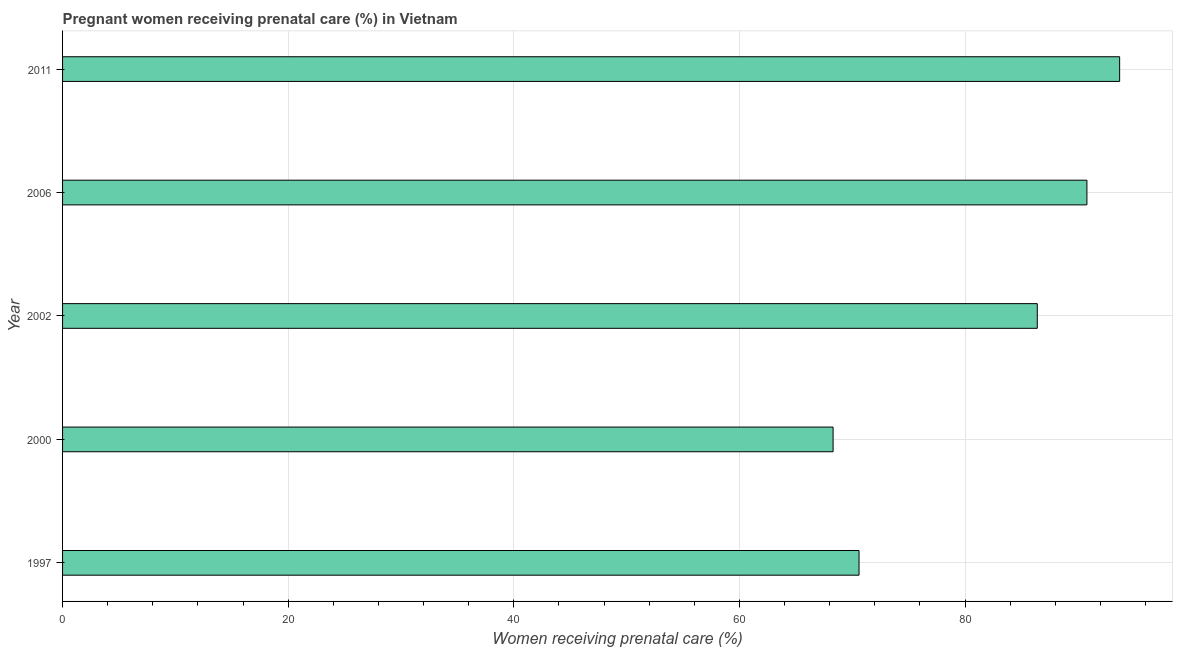Does the graph contain grids?
Offer a very short reply. Yes. What is the title of the graph?
Make the answer very short. Pregnant women receiving prenatal care (%) in Vietnam. What is the label or title of the X-axis?
Your response must be concise. Women receiving prenatal care (%). What is the percentage of pregnant women receiving prenatal care in 1997?
Give a very brief answer. 70.6. Across all years, what is the maximum percentage of pregnant women receiving prenatal care?
Your answer should be compact. 93.7. Across all years, what is the minimum percentage of pregnant women receiving prenatal care?
Offer a very short reply. 68.3. In which year was the percentage of pregnant women receiving prenatal care minimum?
Keep it short and to the point. 2000. What is the sum of the percentage of pregnant women receiving prenatal care?
Ensure brevity in your answer.  409.8. What is the difference between the percentage of pregnant women receiving prenatal care in 2006 and 2011?
Provide a succinct answer. -2.9. What is the average percentage of pregnant women receiving prenatal care per year?
Provide a succinct answer. 81.96. What is the median percentage of pregnant women receiving prenatal care?
Your response must be concise. 86.4. In how many years, is the percentage of pregnant women receiving prenatal care greater than 48 %?
Ensure brevity in your answer.  5. Do a majority of the years between 2000 and 2006 (inclusive) have percentage of pregnant women receiving prenatal care greater than 12 %?
Offer a very short reply. Yes. What is the ratio of the percentage of pregnant women receiving prenatal care in 1997 to that in 2006?
Ensure brevity in your answer.  0.78. Is the percentage of pregnant women receiving prenatal care in 2000 less than that in 2002?
Ensure brevity in your answer.  Yes. Is the difference between the percentage of pregnant women receiving prenatal care in 2002 and 2006 greater than the difference between any two years?
Your answer should be very brief. No. Is the sum of the percentage of pregnant women receiving prenatal care in 2002 and 2011 greater than the maximum percentage of pregnant women receiving prenatal care across all years?
Offer a very short reply. Yes. What is the difference between the highest and the lowest percentage of pregnant women receiving prenatal care?
Your answer should be compact. 25.4. How many bars are there?
Ensure brevity in your answer.  5. How many years are there in the graph?
Make the answer very short. 5. What is the Women receiving prenatal care (%) in 1997?
Your answer should be very brief. 70.6. What is the Women receiving prenatal care (%) of 2000?
Keep it short and to the point. 68.3. What is the Women receiving prenatal care (%) of 2002?
Your answer should be compact. 86.4. What is the Women receiving prenatal care (%) of 2006?
Ensure brevity in your answer.  90.8. What is the Women receiving prenatal care (%) of 2011?
Keep it short and to the point. 93.7. What is the difference between the Women receiving prenatal care (%) in 1997 and 2000?
Offer a terse response. 2.3. What is the difference between the Women receiving prenatal care (%) in 1997 and 2002?
Offer a very short reply. -15.8. What is the difference between the Women receiving prenatal care (%) in 1997 and 2006?
Offer a very short reply. -20.2. What is the difference between the Women receiving prenatal care (%) in 1997 and 2011?
Your response must be concise. -23.1. What is the difference between the Women receiving prenatal care (%) in 2000 and 2002?
Ensure brevity in your answer.  -18.1. What is the difference between the Women receiving prenatal care (%) in 2000 and 2006?
Your answer should be very brief. -22.5. What is the difference between the Women receiving prenatal care (%) in 2000 and 2011?
Provide a succinct answer. -25.4. What is the difference between the Women receiving prenatal care (%) in 2002 and 2011?
Your answer should be compact. -7.3. What is the difference between the Women receiving prenatal care (%) in 2006 and 2011?
Provide a short and direct response. -2.9. What is the ratio of the Women receiving prenatal care (%) in 1997 to that in 2000?
Offer a very short reply. 1.03. What is the ratio of the Women receiving prenatal care (%) in 1997 to that in 2002?
Your response must be concise. 0.82. What is the ratio of the Women receiving prenatal care (%) in 1997 to that in 2006?
Provide a short and direct response. 0.78. What is the ratio of the Women receiving prenatal care (%) in 1997 to that in 2011?
Make the answer very short. 0.75. What is the ratio of the Women receiving prenatal care (%) in 2000 to that in 2002?
Provide a succinct answer. 0.79. What is the ratio of the Women receiving prenatal care (%) in 2000 to that in 2006?
Make the answer very short. 0.75. What is the ratio of the Women receiving prenatal care (%) in 2000 to that in 2011?
Provide a short and direct response. 0.73. What is the ratio of the Women receiving prenatal care (%) in 2002 to that in 2011?
Your response must be concise. 0.92. What is the ratio of the Women receiving prenatal care (%) in 2006 to that in 2011?
Give a very brief answer. 0.97. 